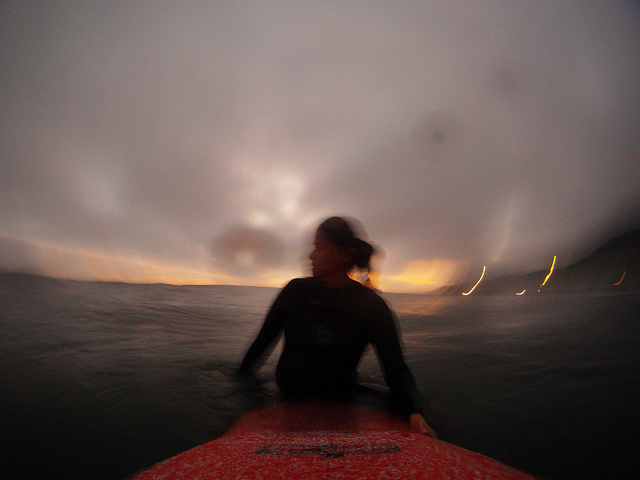What's happening in the scene? In this dynamic and moody scene, captured at sunset with a low-light setting, a person is pictured poised on a surfboard, adorned in a snug-fitting wetsuit that covers from mid-thigh to their shoulders, ideal for the chilly water conditions. The blurred movement and watery backdrop suggest the surfer is actively paddling, possibly preparing to catch a wave as night falls. 